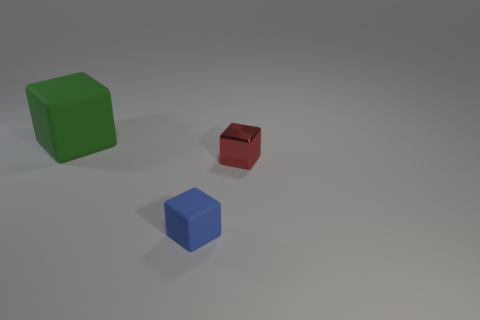Subtract 1 cubes. How many cubes are left? 2 Subtract all big rubber cubes. How many cubes are left? 2 Subtract all brown spheres. How many green blocks are left? 1 Add 1 tiny blue matte cubes. How many objects exist? 4 Subtract all blue blocks. How many blocks are left? 2 Subtract 0 gray cylinders. How many objects are left? 3 Subtract all blue blocks. Subtract all blue cylinders. How many blocks are left? 2 Subtract all big metallic cylinders. Subtract all tiny blocks. How many objects are left? 1 Add 1 blue rubber cubes. How many blue rubber cubes are left? 2 Add 1 gray metallic objects. How many gray metallic objects exist? 1 